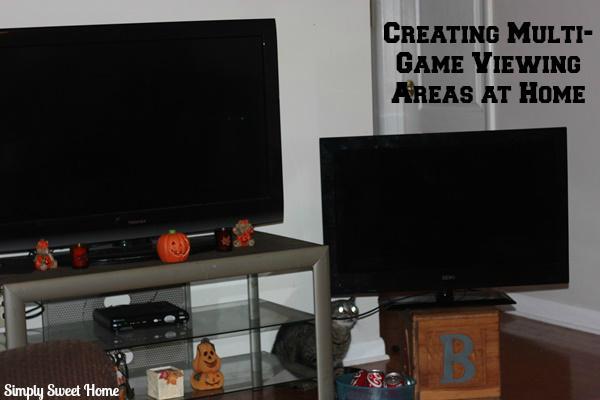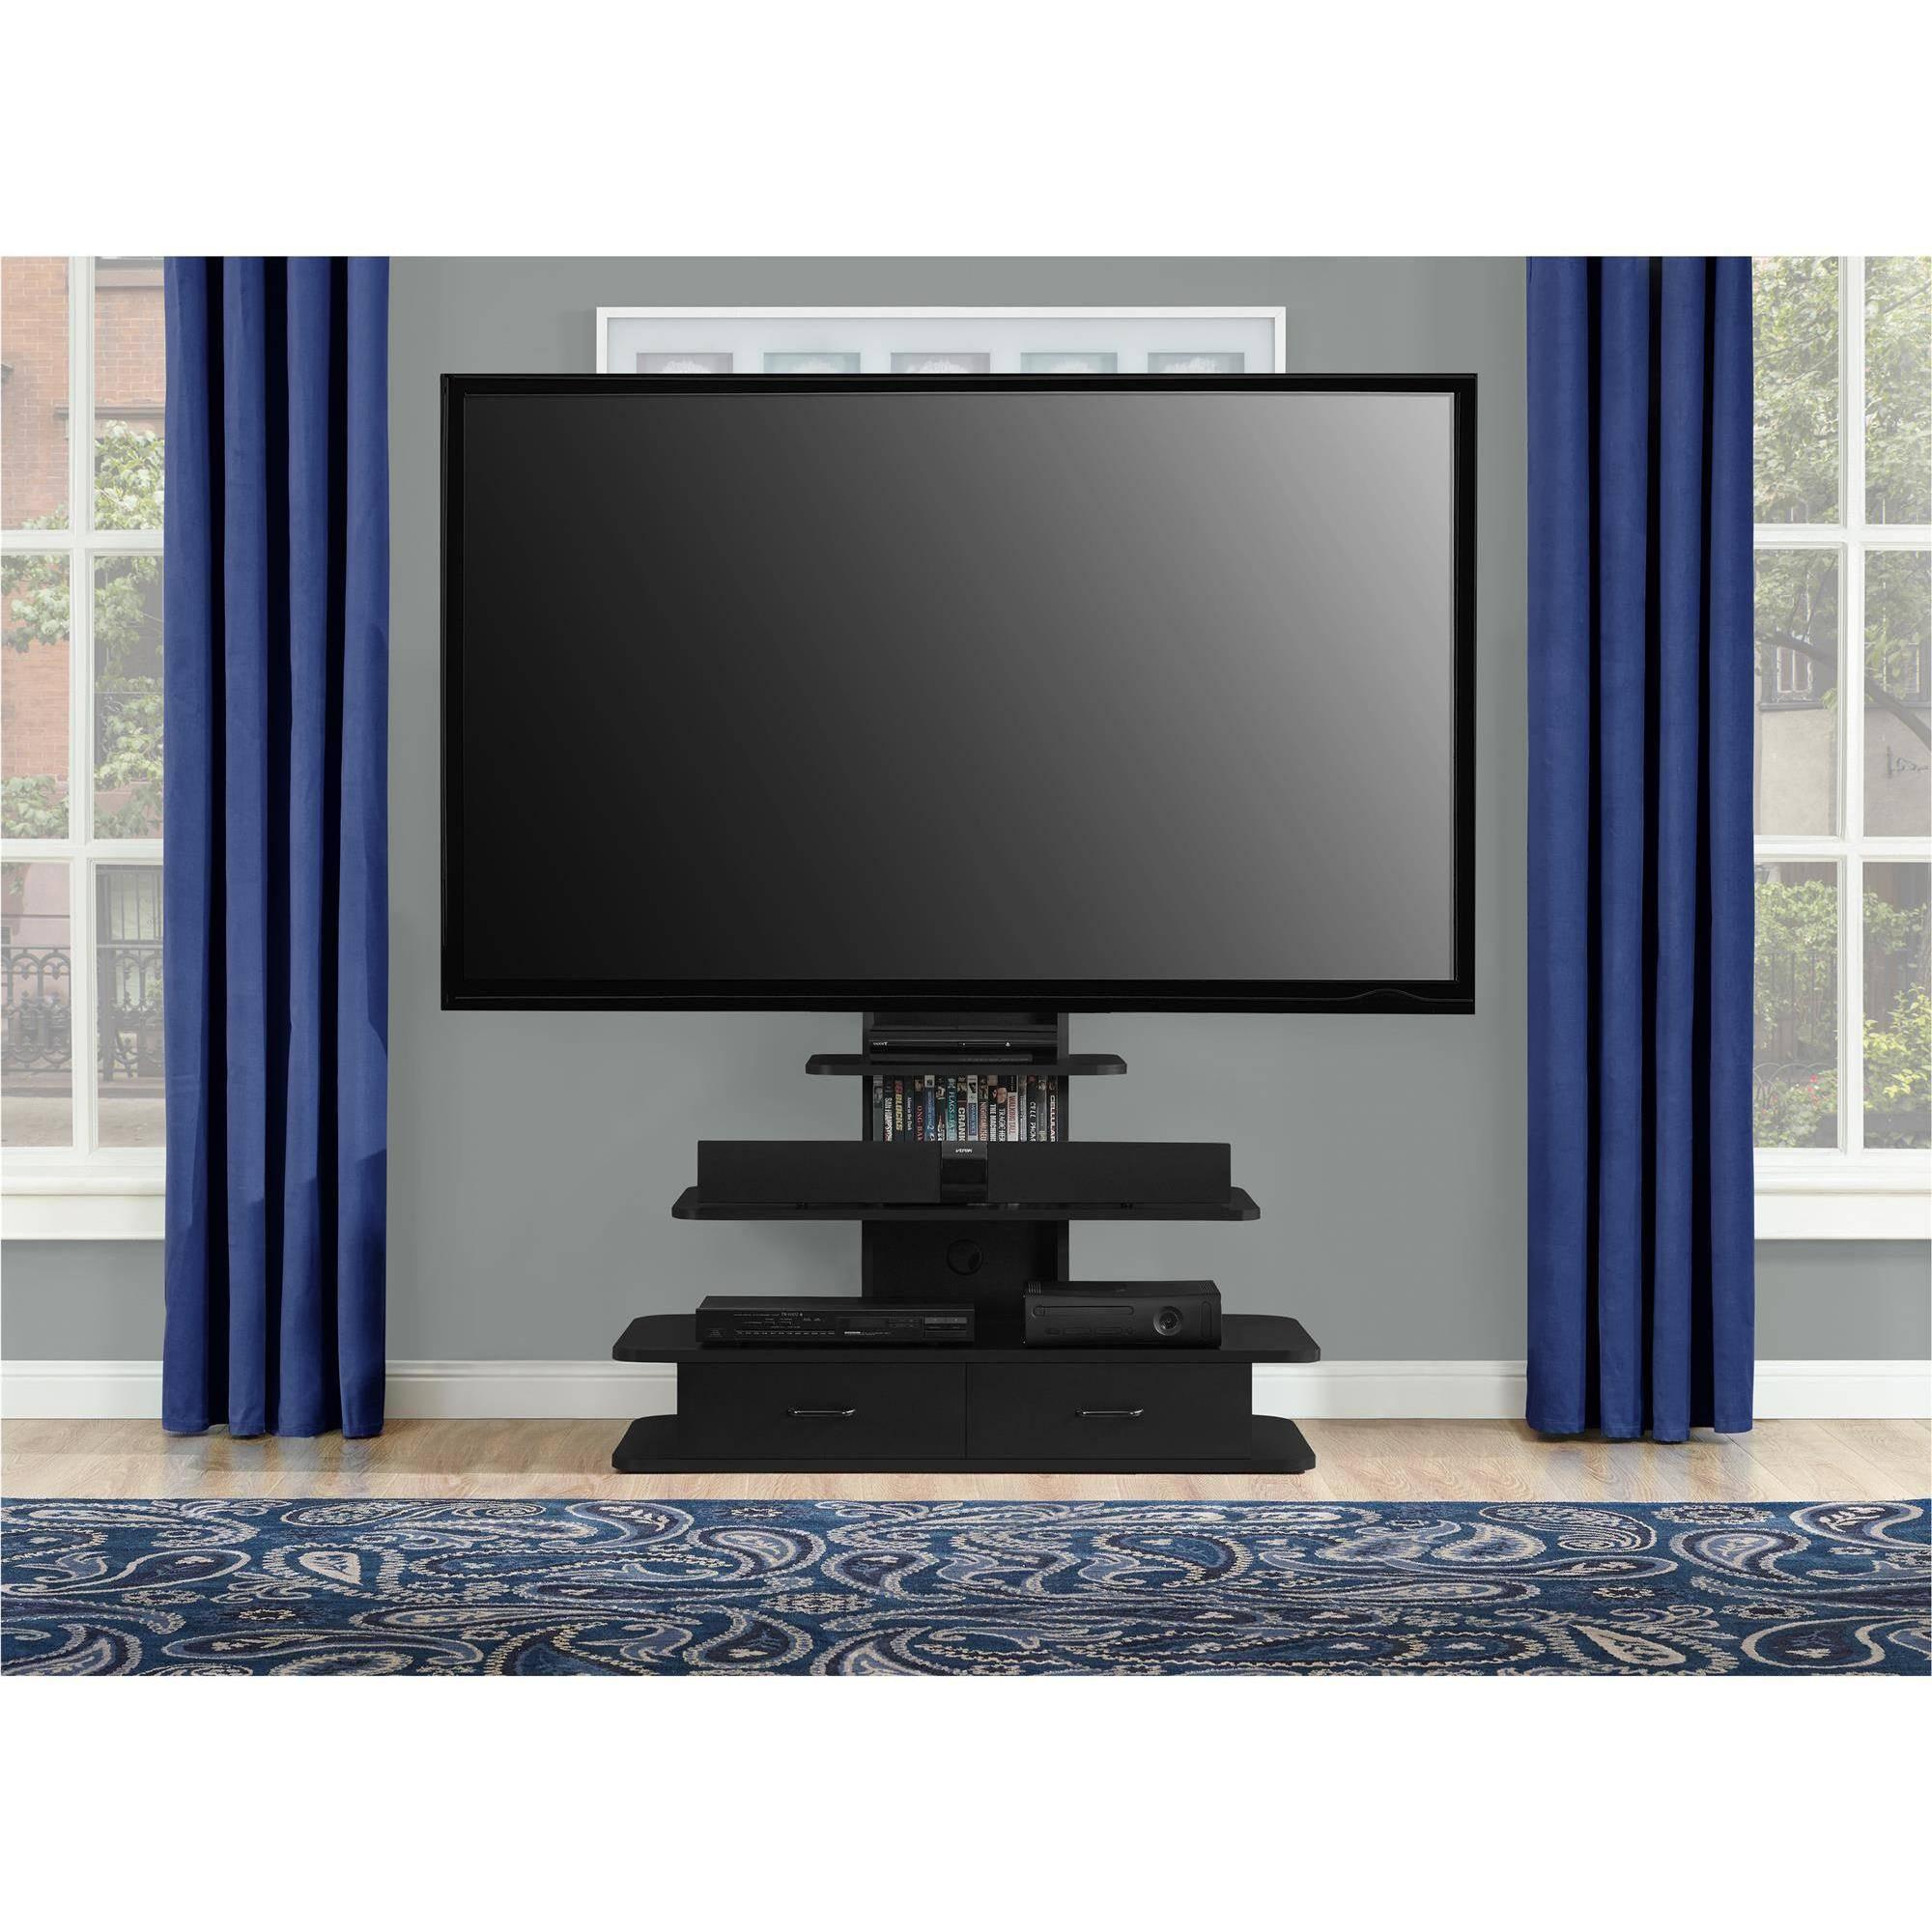The first image is the image on the left, the second image is the image on the right. For the images shown, is this caption "multiple tv's are mounted to a single wall" true? Answer yes or no. No. The first image is the image on the left, the second image is the image on the right. Evaluate the accuracy of this statement regarding the images: "There are multiple screens in the right image.". Is it true? Answer yes or no. No. 